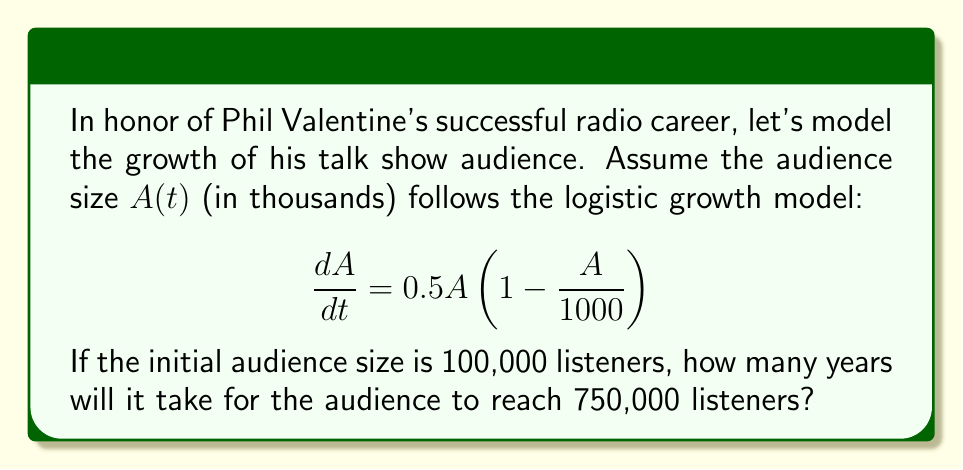Can you solve this math problem? To solve this problem, we'll use the logistic growth model and its solution:

1. The logistic growth model is given by:
   $$\frac{dA}{dt} = rA(1 - \frac{A}{K})$$
   Where $r$ is the growth rate and $K$ is the carrying capacity.

2. In our case, $r = 0.5$ and $K = 1000$ (thousand listeners).

3. The solution to the logistic growth model is:
   $$A(t) = \frac{K}{1 + (\frac{K}{A_0} - 1)e^{-rt}}$$
   Where $A_0$ is the initial population.

4. We're given $A_0 = 100$ (thousand listeners) and we want to find $t$ when $A(t) = 750$ (thousand listeners).

5. Substituting these values into the equation:
   $$750 = \frac{1000}{1 + (\frac{1000}{100} - 1)e^{-0.5t}}$$

6. Simplifying:
   $$750 = \frac{1000}{1 + 9e^{-0.5t}}$$

7. Solving for $t$:
   $$\frac{1000}{750} = 1 + 9e^{-0.5t}$$
   $$\frac{4}{3} = 1 + 9e^{-0.5t}$$
   $$\frac{1}{3} = 9e^{-0.5t}$$
   $$\frac{1}{27} = e^{-0.5t}$$
   $$\ln(\frac{1}{27}) = -0.5t$$
   $$t = \frac{2\ln(27)}{0.5} \approx 6.59$$

Therefore, it will take approximately 6.59 years for Phil Valentine's audience to reach 750,000 listeners.
Answer: 6.59 years 